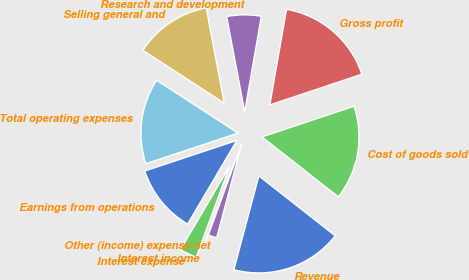Convert chart to OTSL. <chart><loc_0><loc_0><loc_500><loc_500><pie_chart><fcel>Revenue<fcel>Cost of goods sold<fcel>Gross profit<fcel>Research and development<fcel>Selling general and<fcel>Total operating expenses<fcel>Earnings from operations<fcel>Interest expense<fcel>Interest income<fcel>Other (income) expense net<nl><fcel>18.56%<fcel>15.71%<fcel>17.13%<fcel>5.72%<fcel>12.85%<fcel>14.28%<fcel>11.43%<fcel>2.87%<fcel>0.01%<fcel>1.44%<nl></chart> 